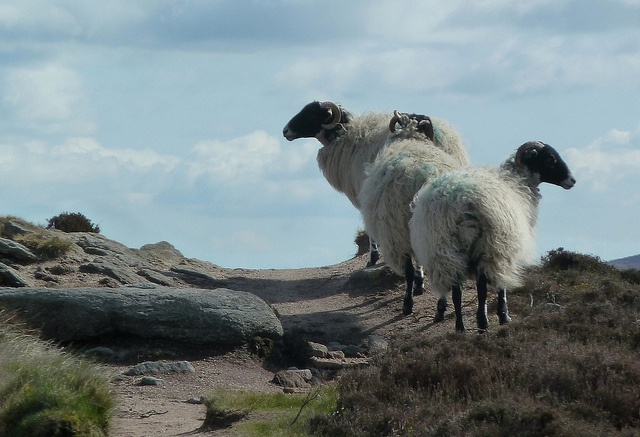Describe the objects in this image and their specific colors. I can see sheep in lightblue, gray, black, darkgray, and lightgray tones, sheep in lightblue, gray, black, and darkgray tones, and sheep in lightblue, gray, black, and darkgray tones in this image. 